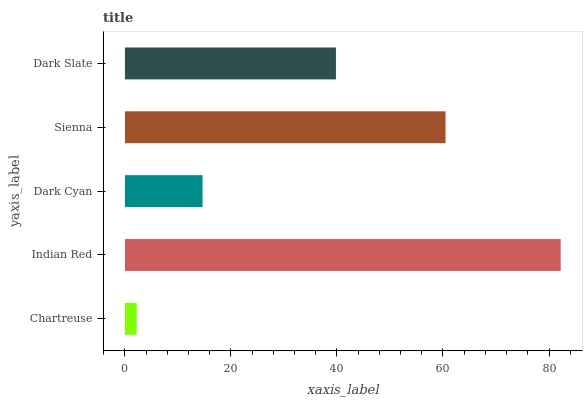Is Chartreuse the minimum?
Answer yes or no. Yes. Is Indian Red the maximum?
Answer yes or no. Yes. Is Dark Cyan the minimum?
Answer yes or no. No. Is Dark Cyan the maximum?
Answer yes or no. No. Is Indian Red greater than Dark Cyan?
Answer yes or no. Yes. Is Dark Cyan less than Indian Red?
Answer yes or no. Yes. Is Dark Cyan greater than Indian Red?
Answer yes or no. No. Is Indian Red less than Dark Cyan?
Answer yes or no. No. Is Dark Slate the high median?
Answer yes or no. Yes. Is Dark Slate the low median?
Answer yes or no. Yes. Is Chartreuse the high median?
Answer yes or no. No. Is Indian Red the low median?
Answer yes or no. No. 